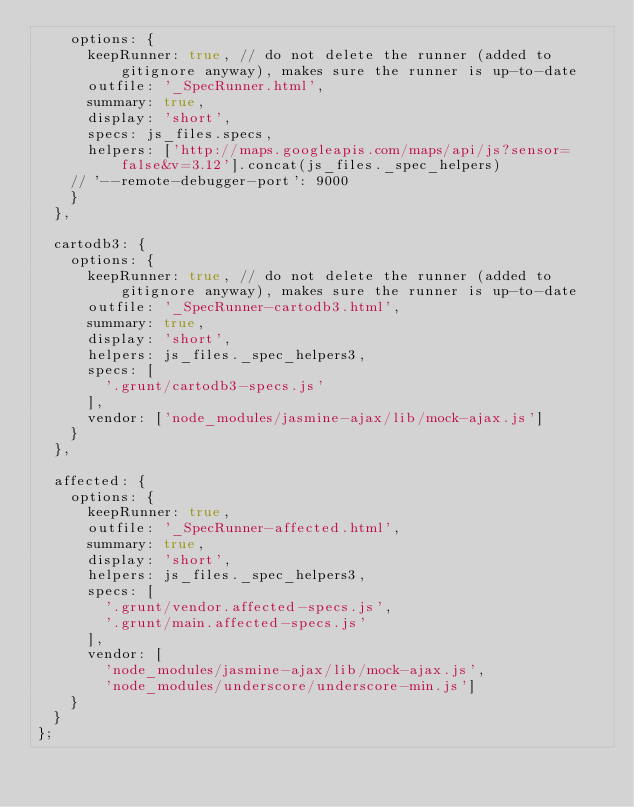<code> <loc_0><loc_0><loc_500><loc_500><_JavaScript_>    options: {
      keepRunner: true, // do not delete the runner (added to gitignore anyway), makes sure the runner is up-to-date
      outfile: '_SpecRunner.html',
      summary: true,
      display: 'short',
      specs: js_files.specs,
      helpers: ['http://maps.googleapis.com/maps/api/js?sensor=false&v=3.12'].concat(js_files._spec_helpers)
    // '--remote-debugger-port': 9000
    }
  },

  cartodb3: {
    options: {
      keepRunner: true, // do not delete the runner (added to gitignore anyway), makes sure the runner is up-to-date
      outfile: '_SpecRunner-cartodb3.html',
      summary: true,
      display: 'short',
      helpers: js_files._spec_helpers3,
      specs: [
        '.grunt/cartodb3-specs.js'
      ],
      vendor: ['node_modules/jasmine-ajax/lib/mock-ajax.js']
    }
  },

  affected: {
    options: {
      keepRunner: true,
      outfile: '_SpecRunner-affected.html',
      summary: true,
      display: 'short',
      helpers: js_files._spec_helpers3,
      specs: [
        '.grunt/vendor.affected-specs.js',
        '.grunt/main.affected-specs.js'
      ],
      vendor: [
        'node_modules/jasmine-ajax/lib/mock-ajax.js',
        'node_modules/underscore/underscore-min.js']
    }
  }
};
</code> 